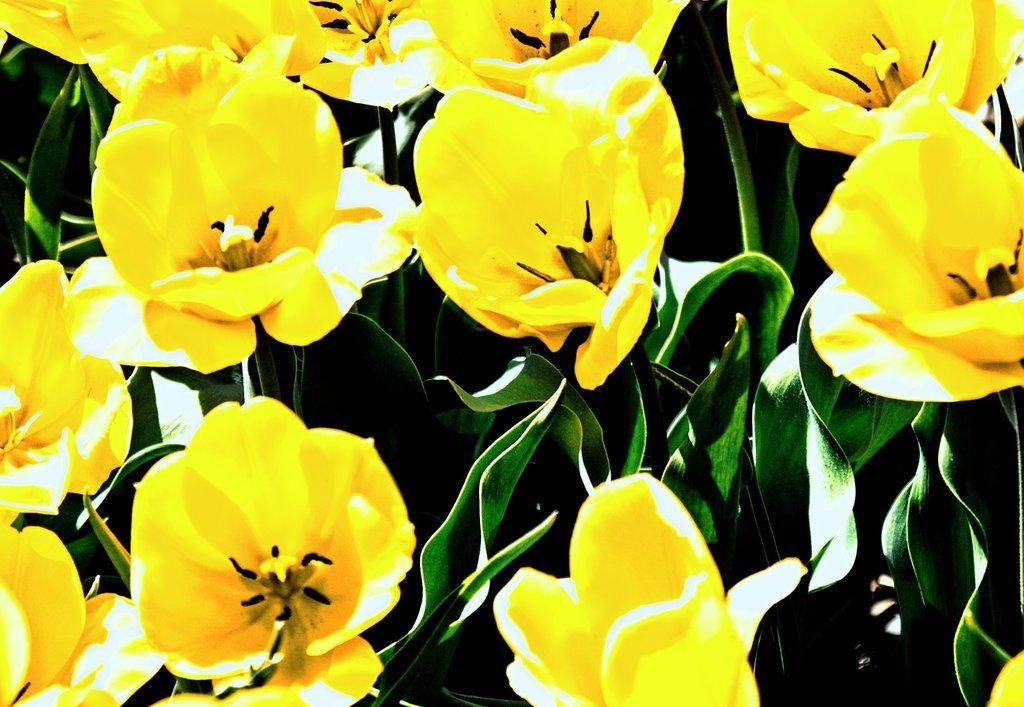What type of living organisms can be seen in the image? There are flowers and plants in the image. Can you describe the plants in the image? The plants in the image are not specified, but they are present alongside the flowers. What color are the toes of the person on the stage in the image? There is no person or stage present in the image; it only features flowers and plants. 